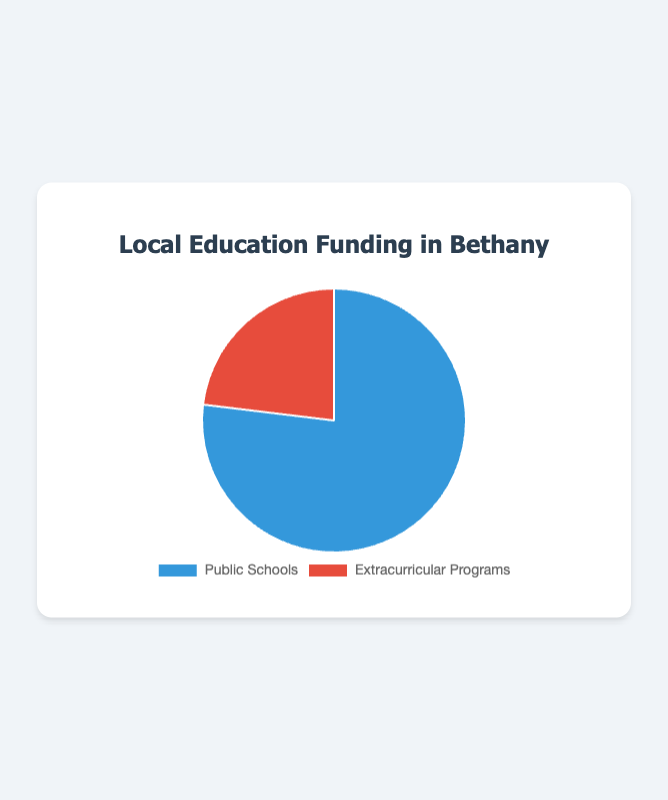What percentage of the total funding is allocated to Public Schools? First, calculate the total funding by adding the funding amounts for both programs: $500,000 (Public Schools) + $150,000 (Extracurricular Programs) = $650,000. Next, divide the funding amount for Public Schools by the total funding and multiply by 100 to get the percentage: ($500,000 / $650,000) * 100 ≈ 76.92%.
Answer: 76.92% How much more funding do Public Schools receive compared to Extracurricular Programs? Subtract the funding amount of Extracurricular Programs from the funding amount of Public Schools: $500,000 (Public Schools) - $150,000 (Extracurricular Programs) = $350,000.
Answer: $350,000 What is the ratio of funding for Public Schools to Extracurricular Programs? Divide the funding amount for Public Schools by the funding amount for Extracurricular Programs: $500,000 / $150,000 ≈ 3.33.
Answer: 3.33 Which funding category has the smaller share, and what color is it represented by in the chart? Extracurricular Programs have the smaller funding share. Visually, they are represented by the red slice in the pie chart.
Answer: Extracurricular Programs, red What fraction of the total funding is allocated to Extracurricular Programs? First, calculate the total funding: $500,000 (Public Schools) + $150,000 (Extracurricular Programs) = $650,000. Next, divide the Extracurricular Programs' funding by the total funding: $150,000 / $650,000 ≈ 0.23, which can be expressed as a fraction roughly equal to 23/100.
Answer: 23/100 By how many times is the Public Schools' funding larger than the Extracurricular Programs' funding? Divide the funding amount for Public Schools by the funding amount for Extracurricular Programs: $500,000 / $150,000 ≈ 3.33 times.
Answer: 3.33 times What is the combined total of the funding amounts represented in the chart? Add the two funding amounts together: $500,000 (Public Schools) + $150,000 (Extracurricular Programs) = $650,000.
Answer: $650,000 